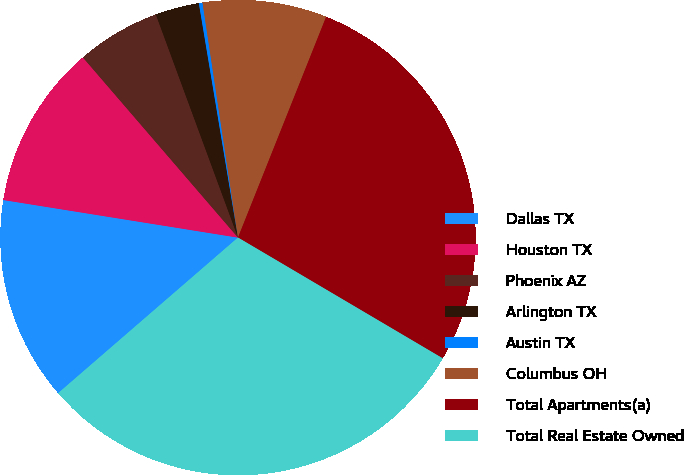Convert chart to OTSL. <chart><loc_0><loc_0><loc_500><loc_500><pie_chart><fcel>Dallas TX<fcel>Houston TX<fcel>Phoenix AZ<fcel>Arlington TX<fcel>Austin TX<fcel>Columbus OH<fcel>Total Apartments(a)<fcel>Total Real Estate Owned<nl><fcel>13.88%<fcel>11.16%<fcel>5.7%<fcel>2.98%<fcel>0.25%<fcel>8.43%<fcel>27.44%<fcel>30.17%<nl></chart> 